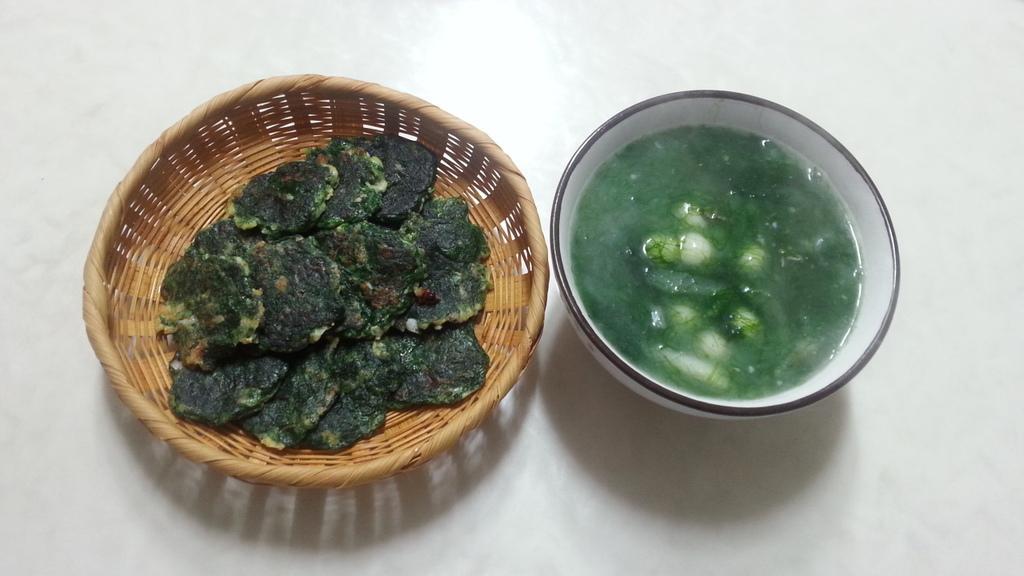How would you summarize this image in a sentence or two? In this picture I can see there is some food in a basket and there is a bowl of soup placed on a white surface. 